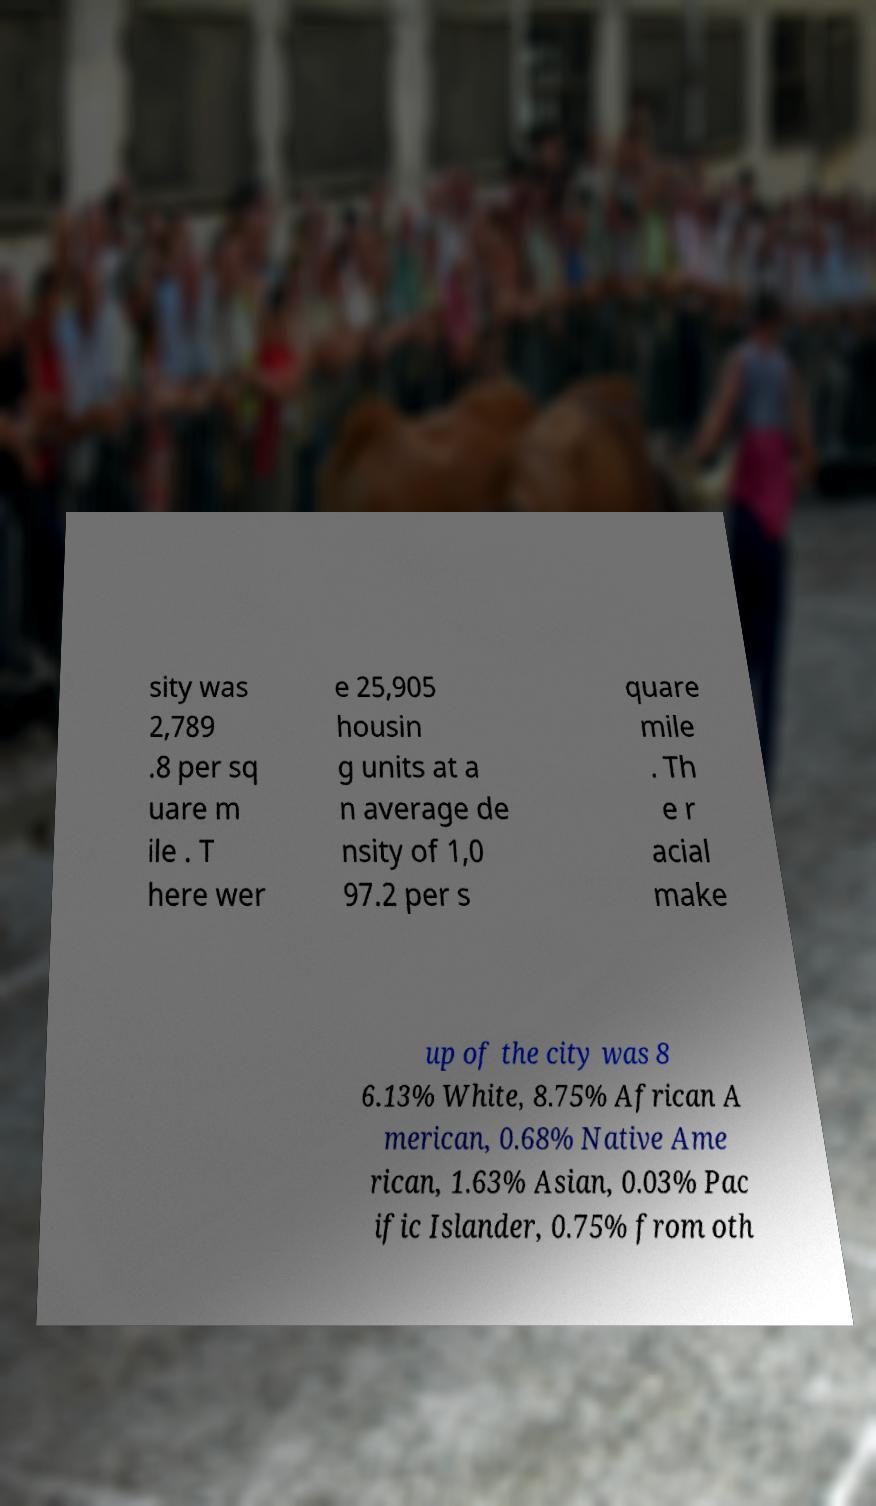Please identify and transcribe the text found in this image. sity was 2,789 .8 per sq uare m ile . T here wer e 25,905 housin g units at a n average de nsity of 1,0 97.2 per s quare mile . Th e r acial make up of the city was 8 6.13% White, 8.75% African A merican, 0.68% Native Ame rican, 1.63% Asian, 0.03% Pac ific Islander, 0.75% from oth 